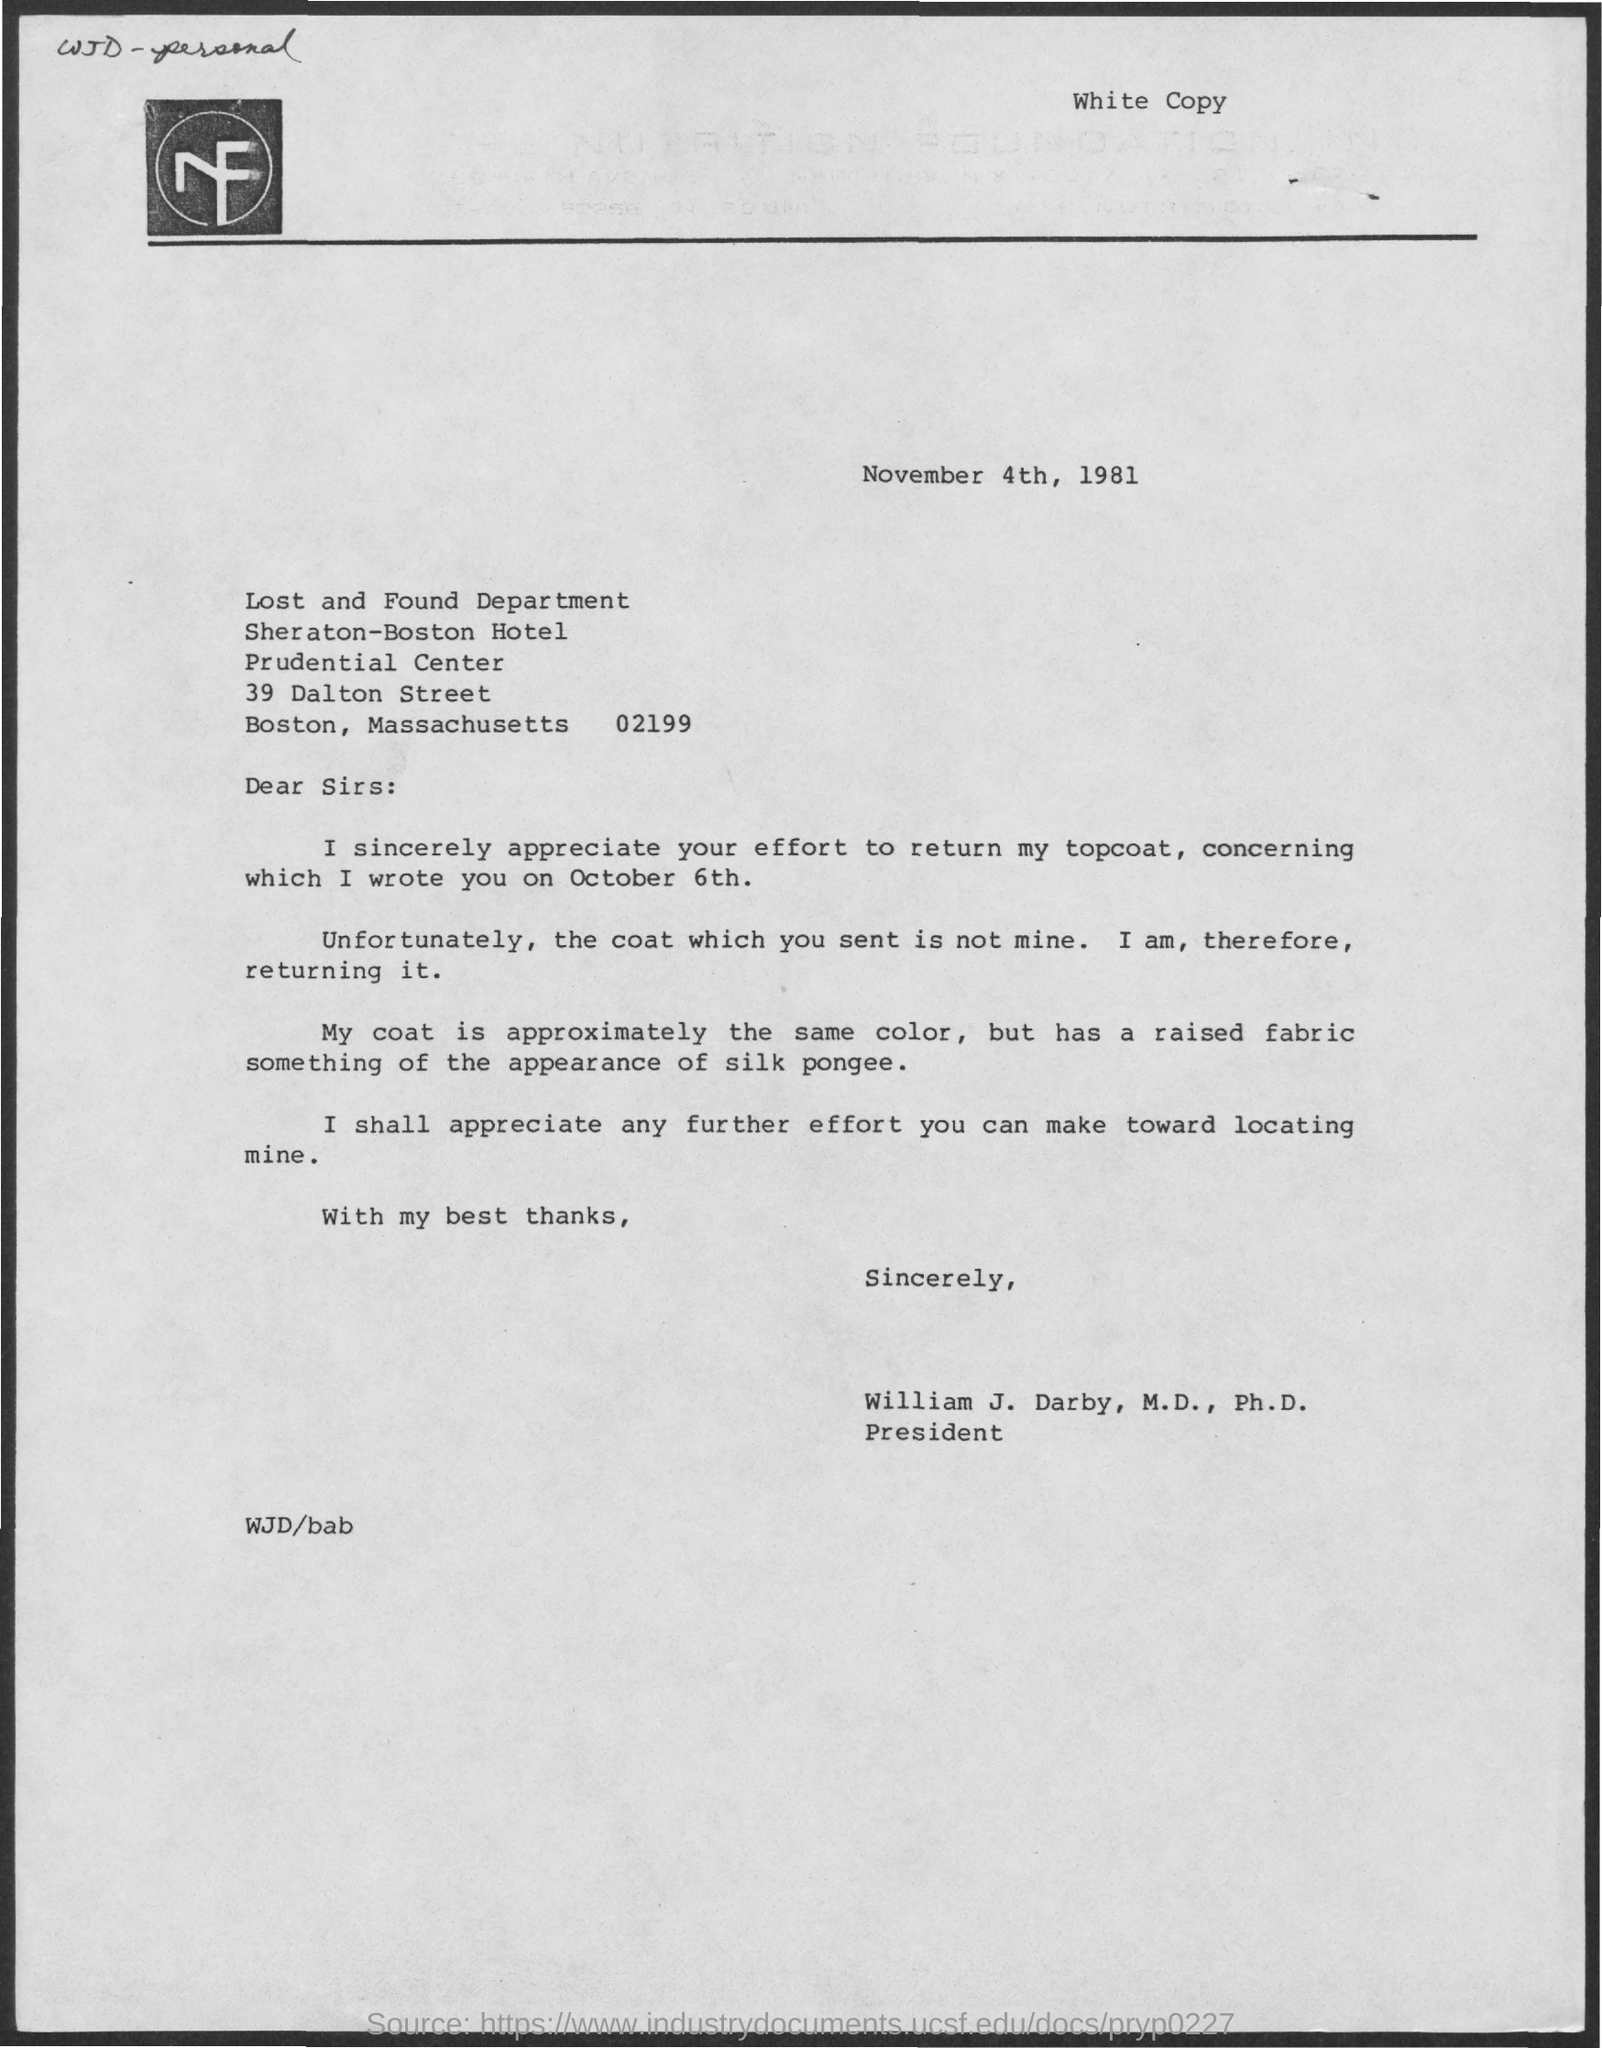Identify some key points in this picture. The name of the department is the Lost and Found Department. 